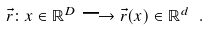<formula> <loc_0><loc_0><loc_500><loc_500>\vec { r } \colon x \in \mathbb { R } ^ { D } \longrightarrow \vec { r } ( x ) \in \mathbb { R } ^ { d } \ .</formula> 